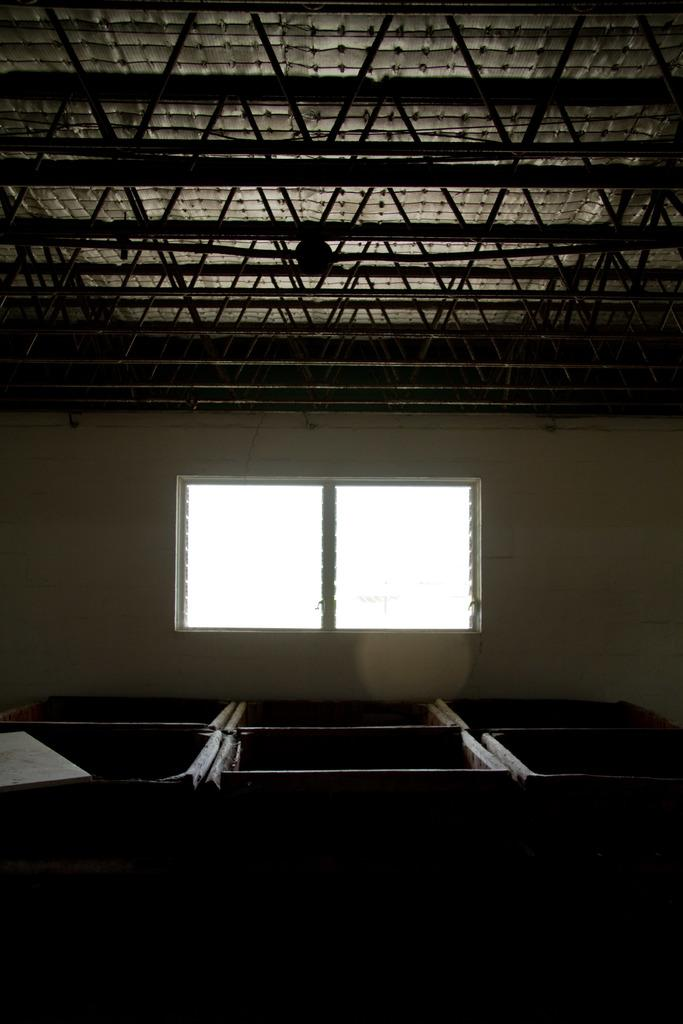What can be seen in the foreground of the image? There are objects in the foreground of the image. What is visible in the background of the image? There is a window and a roof in the background of the image. What type of trousers can be seen hanging from the roof in the image? There are no trousers present in the image; the background features a window and a roof. How many bricks are visible in the image? There is no mention of bricks in the image, as it only describes objects in the foreground and a window and roof in the background. 